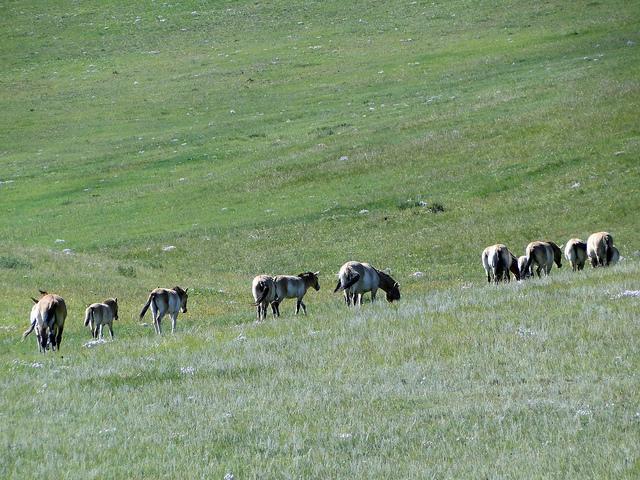What is on the grass?
Choose the correct response and explain in the format: 'Answer: answer
Rationale: rationale.'
Options: Statues, animals, scarecrows, dancing seniors. Answer: animals.
Rationale: A group of horses is grazing in an open area. 